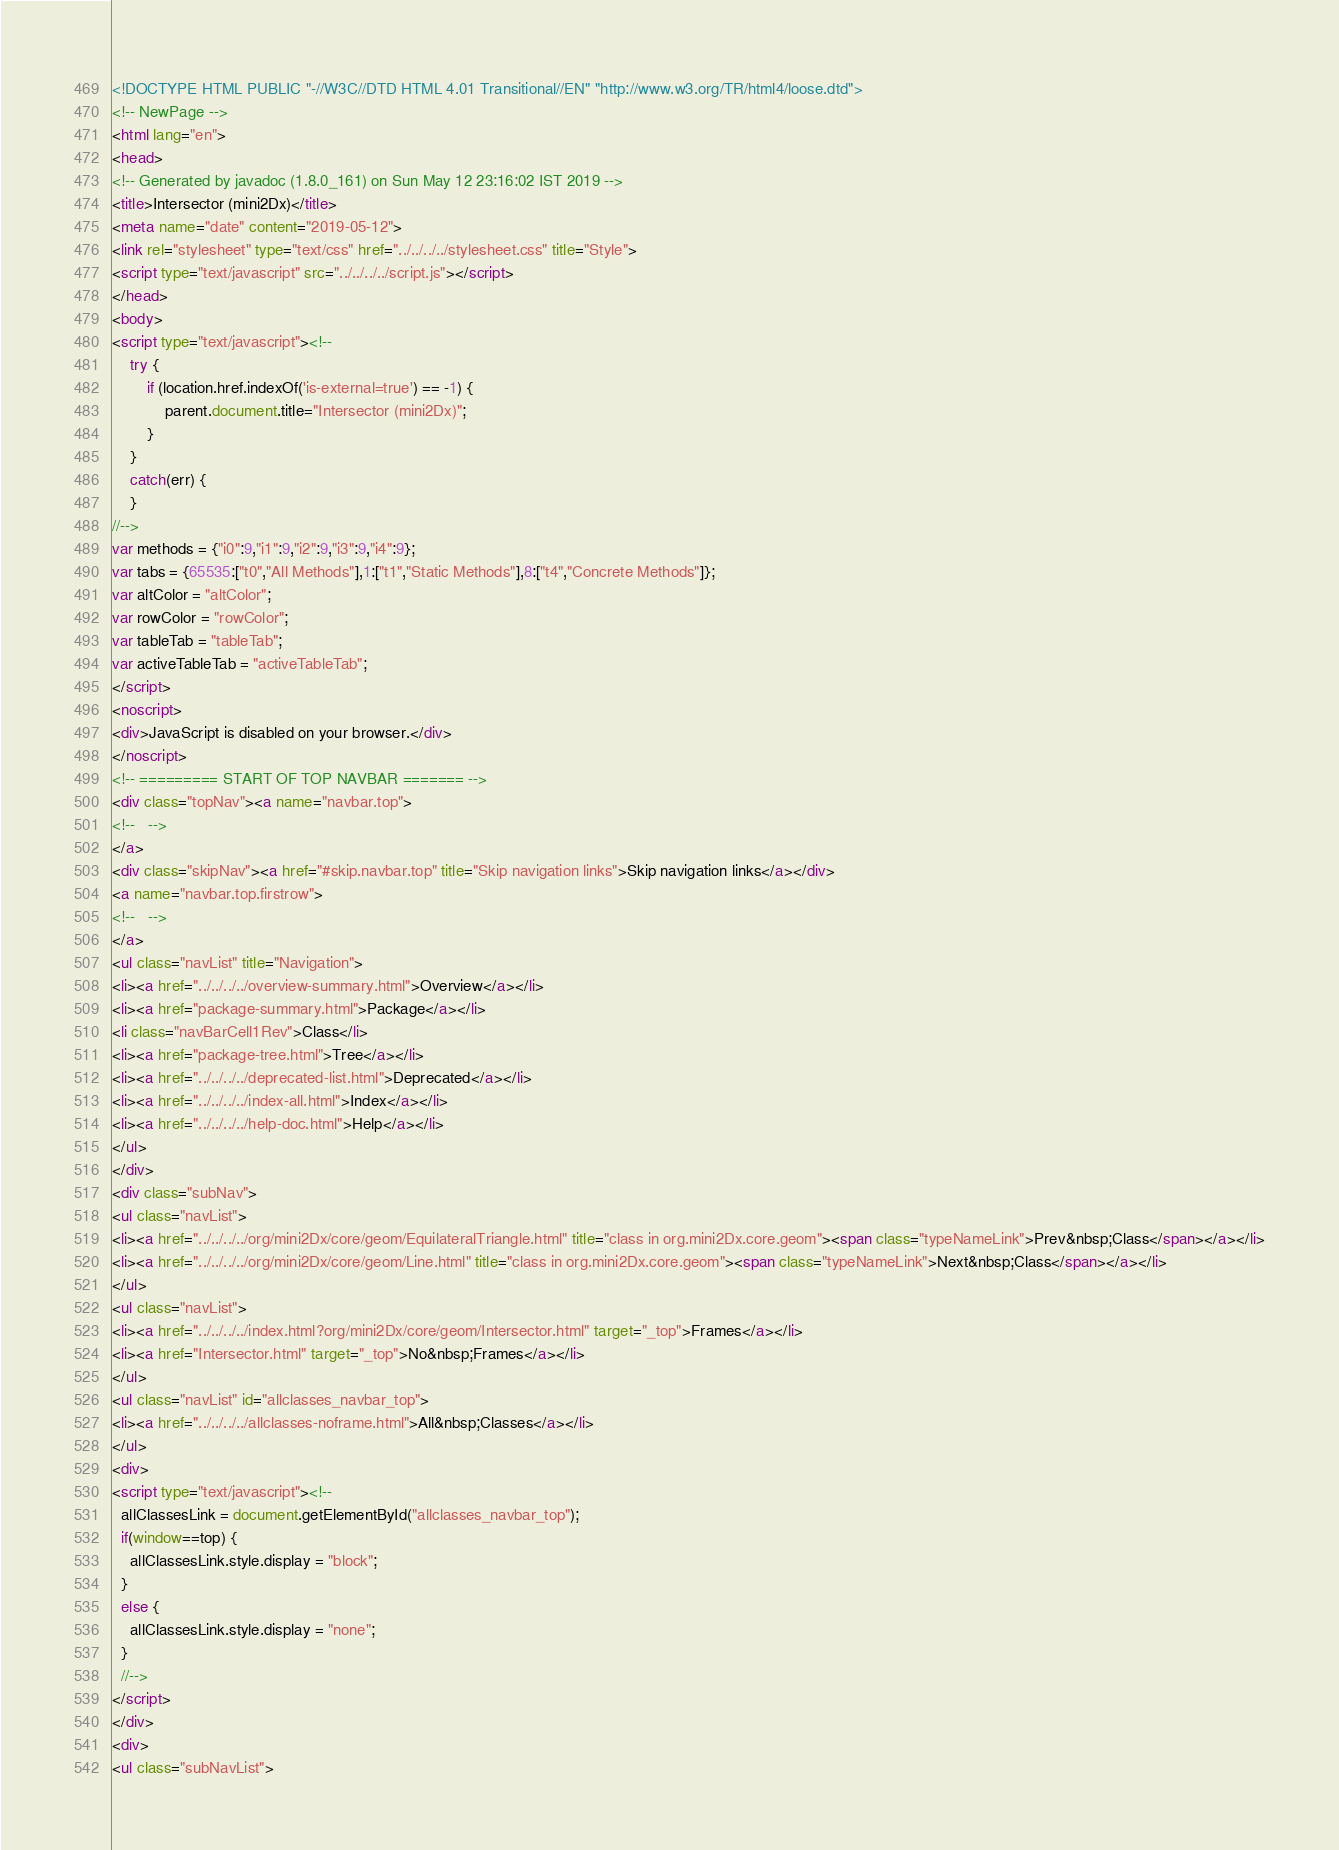<code> <loc_0><loc_0><loc_500><loc_500><_HTML_><!DOCTYPE HTML PUBLIC "-//W3C//DTD HTML 4.01 Transitional//EN" "http://www.w3.org/TR/html4/loose.dtd">
<!-- NewPage -->
<html lang="en">
<head>
<!-- Generated by javadoc (1.8.0_161) on Sun May 12 23:16:02 IST 2019 -->
<title>Intersector (mini2Dx)</title>
<meta name="date" content="2019-05-12">
<link rel="stylesheet" type="text/css" href="../../../../stylesheet.css" title="Style">
<script type="text/javascript" src="../../../../script.js"></script>
</head>
<body>
<script type="text/javascript"><!--
    try {
        if (location.href.indexOf('is-external=true') == -1) {
            parent.document.title="Intersector (mini2Dx)";
        }
    }
    catch(err) {
    }
//-->
var methods = {"i0":9,"i1":9,"i2":9,"i3":9,"i4":9};
var tabs = {65535:["t0","All Methods"],1:["t1","Static Methods"],8:["t4","Concrete Methods"]};
var altColor = "altColor";
var rowColor = "rowColor";
var tableTab = "tableTab";
var activeTableTab = "activeTableTab";
</script>
<noscript>
<div>JavaScript is disabled on your browser.</div>
</noscript>
<!-- ========= START OF TOP NAVBAR ======= -->
<div class="topNav"><a name="navbar.top">
<!--   -->
</a>
<div class="skipNav"><a href="#skip.navbar.top" title="Skip navigation links">Skip navigation links</a></div>
<a name="navbar.top.firstrow">
<!--   -->
</a>
<ul class="navList" title="Navigation">
<li><a href="../../../../overview-summary.html">Overview</a></li>
<li><a href="package-summary.html">Package</a></li>
<li class="navBarCell1Rev">Class</li>
<li><a href="package-tree.html">Tree</a></li>
<li><a href="../../../../deprecated-list.html">Deprecated</a></li>
<li><a href="../../../../index-all.html">Index</a></li>
<li><a href="../../../../help-doc.html">Help</a></li>
</ul>
</div>
<div class="subNav">
<ul class="navList">
<li><a href="../../../../org/mini2Dx/core/geom/EquilateralTriangle.html" title="class in org.mini2Dx.core.geom"><span class="typeNameLink">Prev&nbsp;Class</span></a></li>
<li><a href="../../../../org/mini2Dx/core/geom/Line.html" title="class in org.mini2Dx.core.geom"><span class="typeNameLink">Next&nbsp;Class</span></a></li>
</ul>
<ul class="navList">
<li><a href="../../../../index.html?org/mini2Dx/core/geom/Intersector.html" target="_top">Frames</a></li>
<li><a href="Intersector.html" target="_top">No&nbsp;Frames</a></li>
</ul>
<ul class="navList" id="allclasses_navbar_top">
<li><a href="../../../../allclasses-noframe.html">All&nbsp;Classes</a></li>
</ul>
<div>
<script type="text/javascript"><!--
  allClassesLink = document.getElementById("allclasses_navbar_top");
  if(window==top) {
    allClassesLink.style.display = "block";
  }
  else {
    allClassesLink.style.display = "none";
  }
  //-->
</script>
</div>
<div>
<ul class="subNavList"></code> 